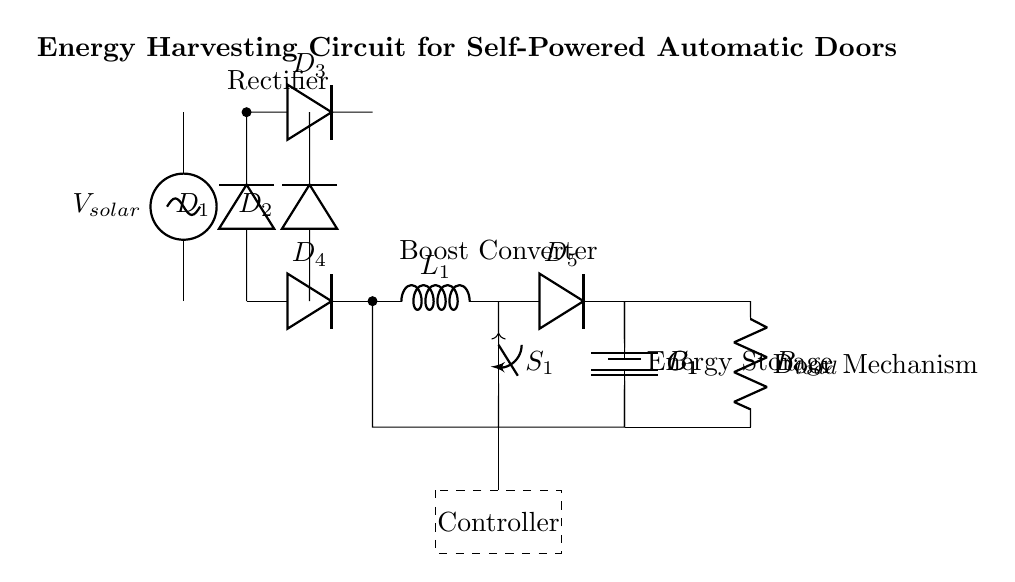What is the voltage source in this circuit? The circuit includes a solar panel as the voltage source, labeled as V solar. This source provides energy to the rectifier.
Answer: V solar How many diodes are present in the circuit? There are four diodes labeled D1, D2, D3, and D4 positioned in two separate pathways for the rectification process.
Answer: Four What component is used for energy storage? The circuit uses a battery, specifically labeled as B1, to store energy harvested from the solar panel after conversion.
Answer: B1 What does the controller do in this circuit? The dashed rectangle labeled as Controller indicates that it is responsible for managing the charging and discharging of the battery, ensuring the energy from the solar panel is efficiently used.
Answer: Manage energy Which component is responsible for converting direct current to a higher voltage? The boost converter, labeled as L1, is responsible for stepping up the voltage from the solar panel output to a higher level suitable for the load.
Answer: Boost converter What role does the switch S1 play in this circuit? The switch S1 allows for controlling the connection between the output of the boost converter and the load, enabling on/off control of the energy supply to the door mechanism.
Answer: Control connection What is the load in this circuit? The load is represented by R load, which connects to the energy storage and is powered by the stored energy to operate the automatic door mechanism.
Answer: R load 